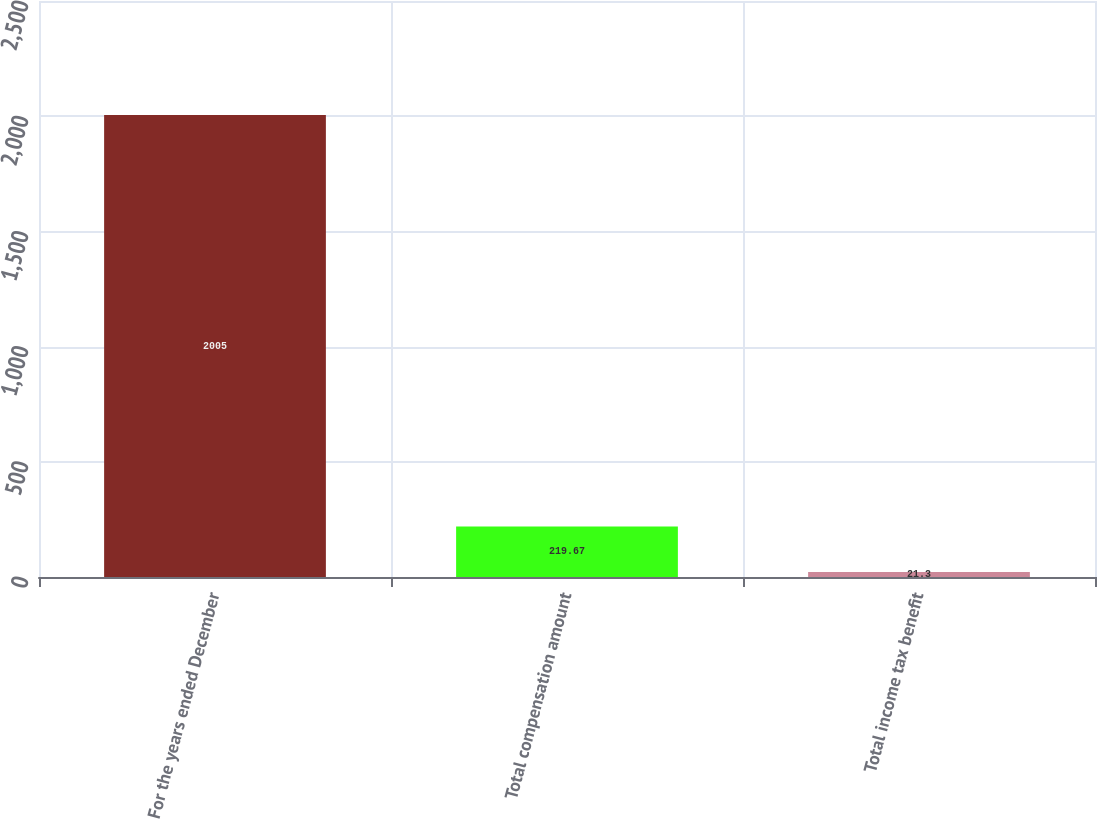Convert chart. <chart><loc_0><loc_0><loc_500><loc_500><bar_chart><fcel>For the years ended December<fcel>Total compensation amount<fcel>Total income tax benefit<nl><fcel>2005<fcel>219.67<fcel>21.3<nl></chart> 